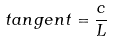Convert formula to latex. <formula><loc_0><loc_0><loc_500><loc_500>t a n g e n t = \frac { c } { L }</formula> 